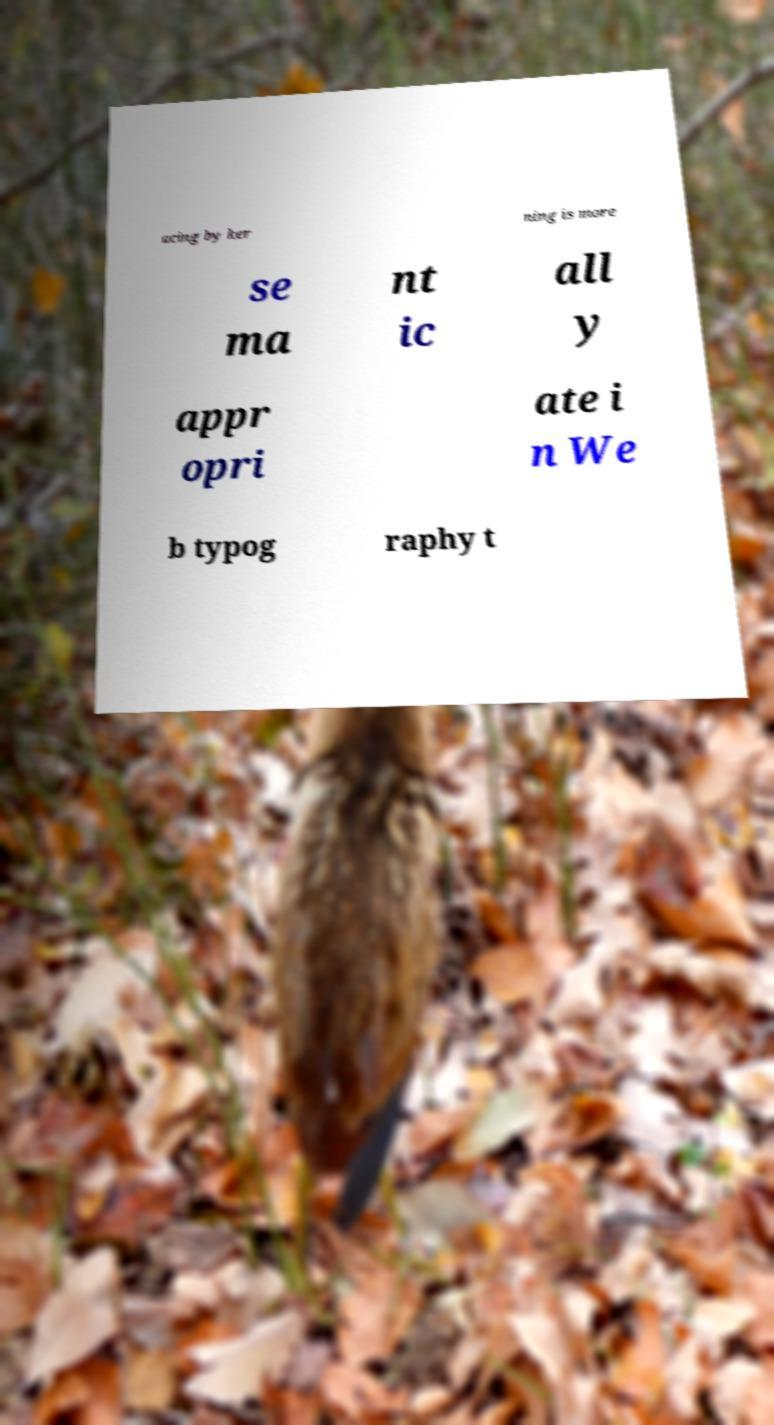Could you assist in decoding the text presented in this image and type it out clearly? acing by ker ning is more se ma nt ic all y appr opri ate i n We b typog raphy t 